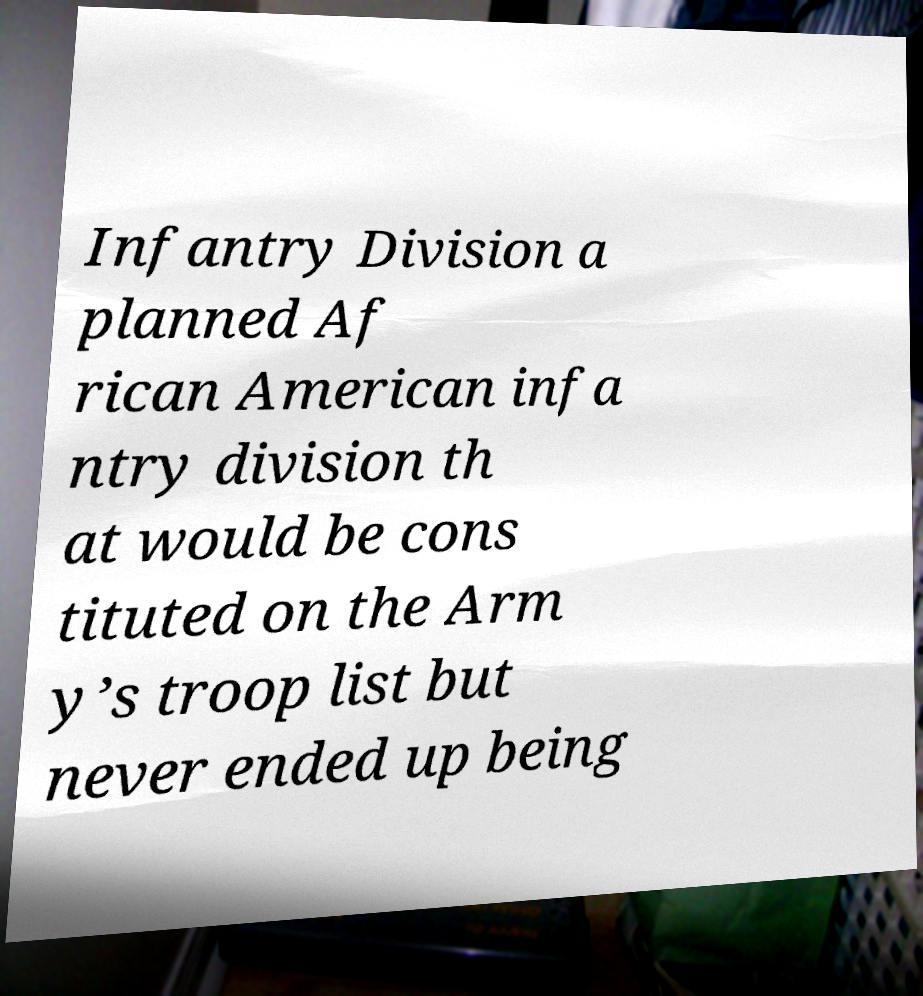Could you assist in decoding the text presented in this image and type it out clearly? Infantry Division a planned Af rican American infa ntry division th at would be cons tituted on the Arm y’s troop list but never ended up being 